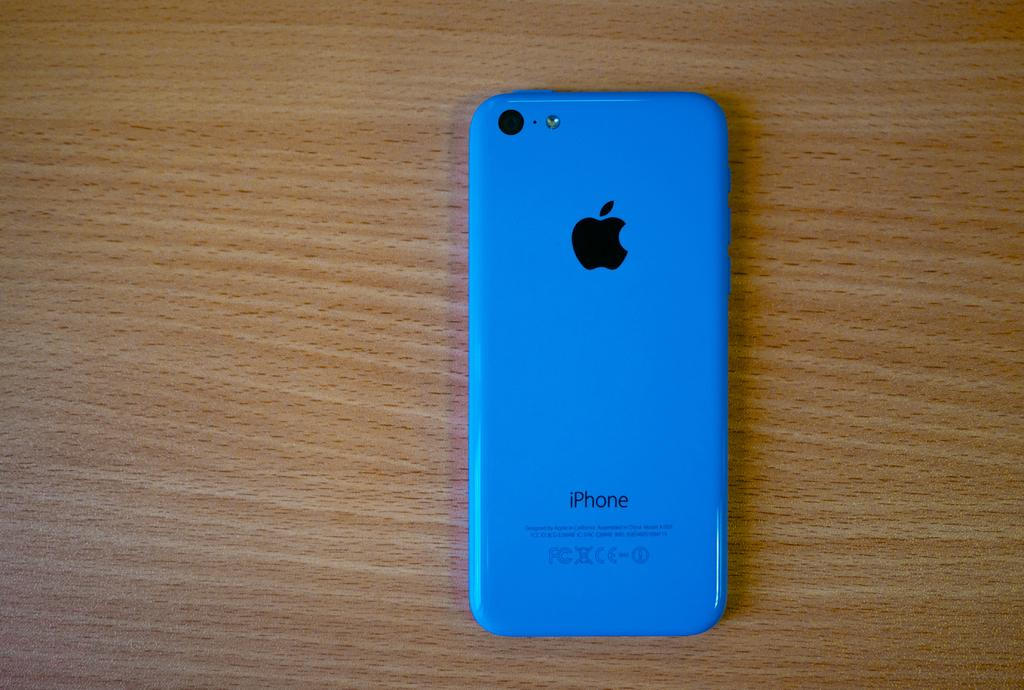<image>
Relay a brief, clear account of the picture shown. The back of a blue cellphone which reads iPhone 